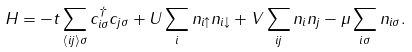Convert formula to latex. <formula><loc_0><loc_0><loc_500><loc_500>H = - t \sum _ { \langle i j \rangle \sigma } c _ { i \sigma } ^ { \dagger } c _ { j \sigma } + U \sum _ { i } n _ { i \uparrow } n _ { i \downarrow } + V \sum _ { i j } n _ { i } n _ { j } - \mu \sum _ { i \sigma } n _ { i \sigma } .</formula> 